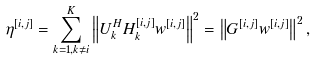Convert formula to latex. <formula><loc_0><loc_0><loc_500><loc_500>\eta ^ { [ i , j ] } = \sum _ { k = 1 , k \neq i } ^ { K } \left \| U _ { k } ^ { H } H _ { k } ^ { [ i , j ] } w ^ { [ i , j ] } \right \| ^ { 2 } = \left \| G ^ { [ i , j ] } w ^ { [ i , j ] } \right \| ^ { 2 } ,</formula> 